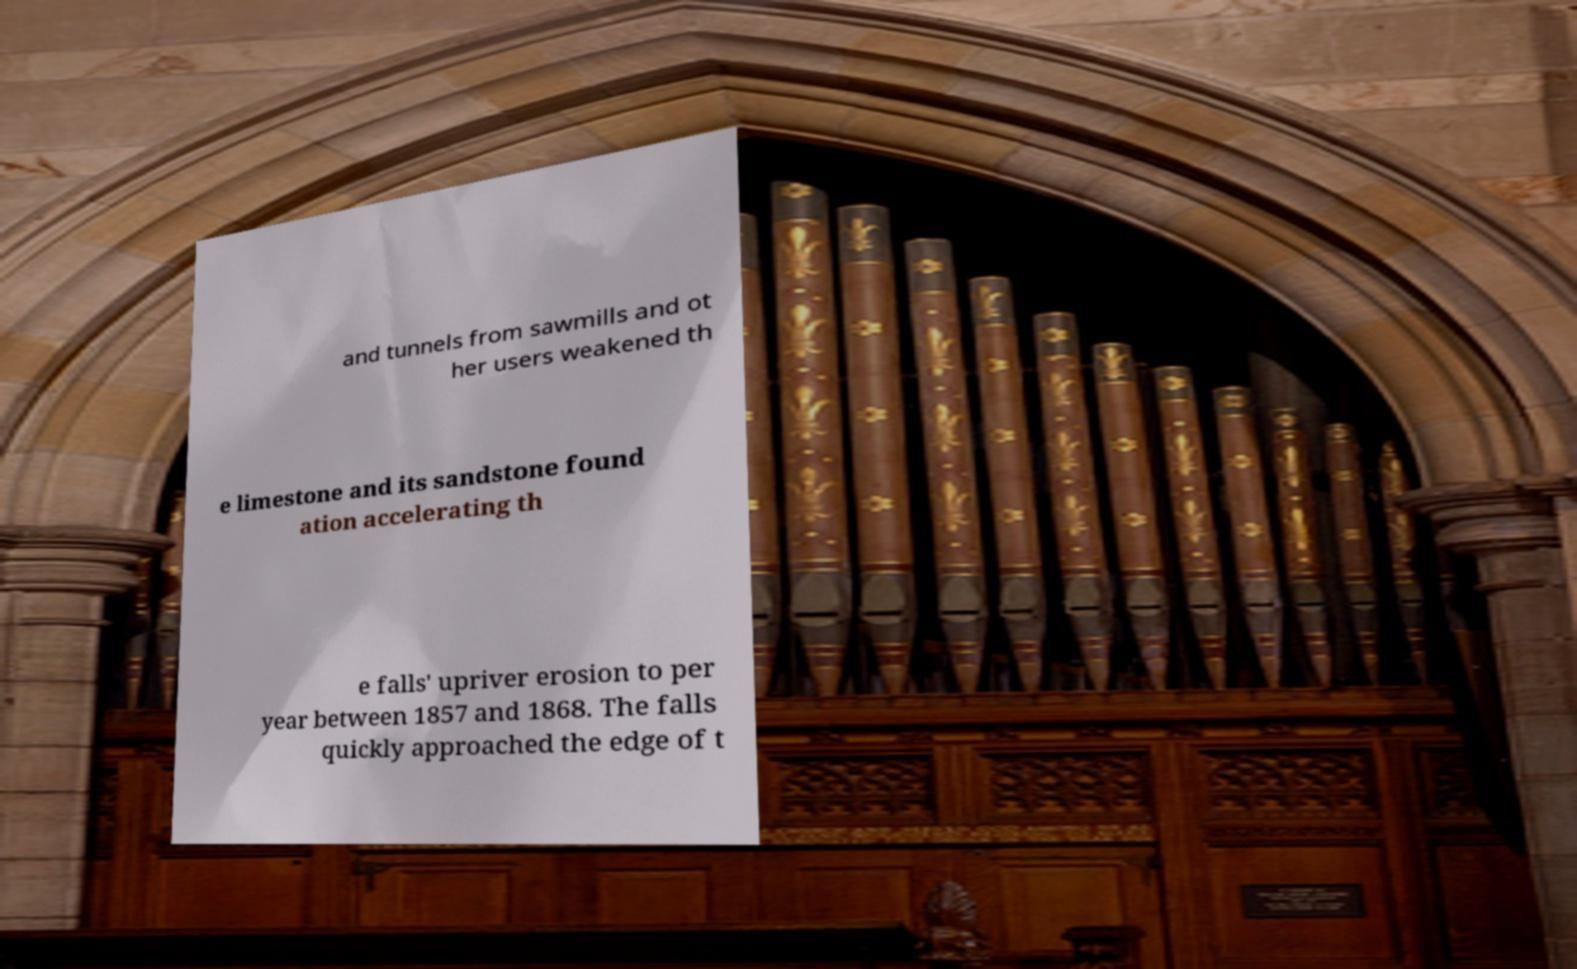Please read and relay the text visible in this image. What does it say? and tunnels from sawmills and ot her users weakened th e limestone and its sandstone found ation accelerating th e falls' upriver erosion to per year between 1857 and 1868. The falls quickly approached the edge of t 